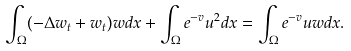<formula> <loc_0><loc_0><loc_500><loc_500>\int _ { \Omega } ( - \Delta w _ { t } + w _ { t } ) w d x + \int _ { \Omega } e ^ { - v } u ^ { 2 } d x = \int _ { \Omega } e ^ { - v } u w d x .</formula> 